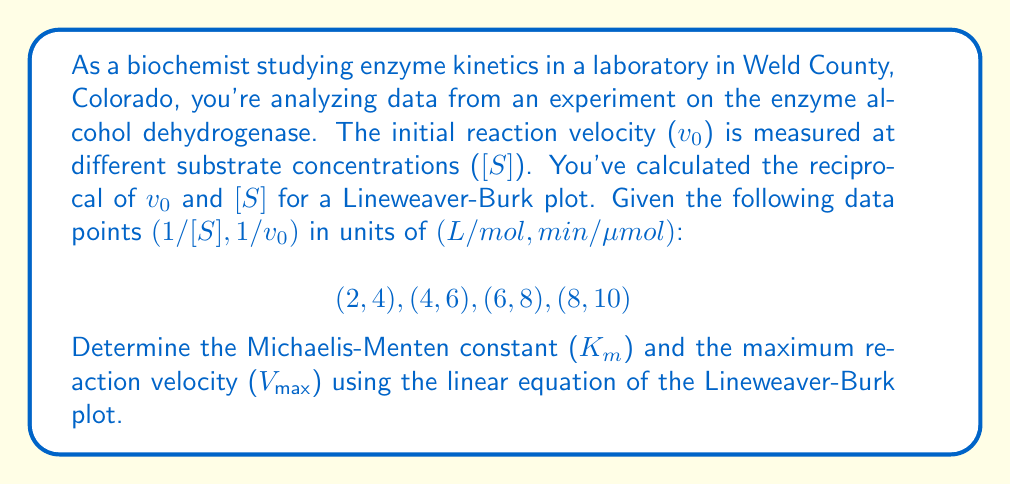Give your solution to this math problem. Let's approach this step-by-step:

1) The Lineweaver-Burk equation is a linear transformation of the Michaelis-Menten equation:

   $$\frac{1}{v_0} = \frac{K_m}{V_{max}} \cdot \frac{1}{[S]} + \frac{1}{V_{max}}$$

   This is in the form of $y = mx + b$, where:
   - $y = \frac{1}{v_0}$
   - $x = \frac{1}{[S]}$
   - $m = \frac{K_m}{V_{max}}$ (slope)
   - $b = \frac{1}{V_{max}}$ (y-intercept)

2) To find the slope and y-intercept, we can use the given data points to calculate:

   $$m = \frac{y_2 - y_1}{x_2 - x_1} = \frac{10 - 4}{8 - 2} = \frac{6}{6} = 1$$

   $$b = y - mx = 4 - 1(2) = 2$$

3) Therefore, our Lineweaver-Burk equation is:

   $$\frac{1}{v_0} = 1 \cdot \frac{1}{[S]} + 2$$

4) From this, we can determine:

   $\frac{1}{V_{max}} = 2$, so $V_{max} = \frac{1}{2} = 0.5$ μmol/min

   $\frac{K_m}{V_{max}} = 1$, so $K_m = V_{max} \cdot 1 = 0.5$ mol/L
Answer: $K_m = 0.5$ mol/L, $V_{max} = 0.5$ μmol/min 